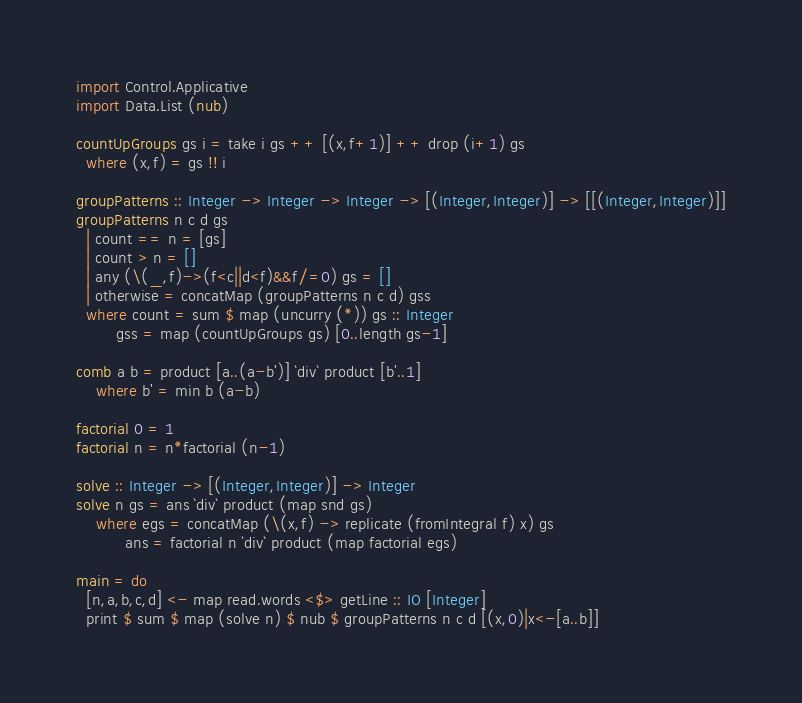Convert code to text. <code><loc_0><loc_0><loc_500><loc_500><_Haskell_>import Control.Applicative
import Data.List (nub)

countUpGroups gs i = take i gs ++ [(x,f+1)] ++ drop (i+1) gs
  where (x,f) = gs !! i

groupPatterns :: Integer -> Integer -> Integer -> [(Integer,Integer)] -> [[(Integer,Integer)]]
groupPatterns n c d gs
  | count == n = [gs]
  | count > n = []
  | any (\(_,f)->(f<c||d<f)&&f/=0) gs = []
  | otherwise = concatMap (groupPatterns n c d) gss
  where count = sum $ map (uncurry (*)) gs :: Integer
        gss = map (countUpGroups gs) [0..length gs-1]

comb a b = product [a..(a-b')] `div` product [b'..1]
    where b' = min b (a-b)

factorial 0 = 1
factorial n = n*factorial (n-1)

solve :: Integer -> [(Integer,Integer)] -> Integer
solve n gs = ans `div` product (map snd gs)
    where egs = concatMap (\(x,f) -> replicate (fromIntegral f) x) gs
          ans = factorial n `div` product (map factorial egs)

main = do
  [n,a,b,c,d] <- map read.words <$> getLine :: IO [Integer]
  print $ sum $ map (solve n) $ nub $ groupPatterns n c d [(x,0)|x<-[a..b]]
</code> 